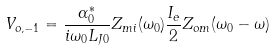<formula> <loc_0><loc_0><loc_500><loc_500>V _ { o , - 1 } = \frac { \alpha _ { 0 } ^ { * } } { i \omega _ { 0 } L _ { J 0 } } Z _ { m i } ( \omega _ { 0 } ) \frac { I _ { e } } { 2 } Z _ { o m } ( \omega _ { 0 } - \omega )</formula> 